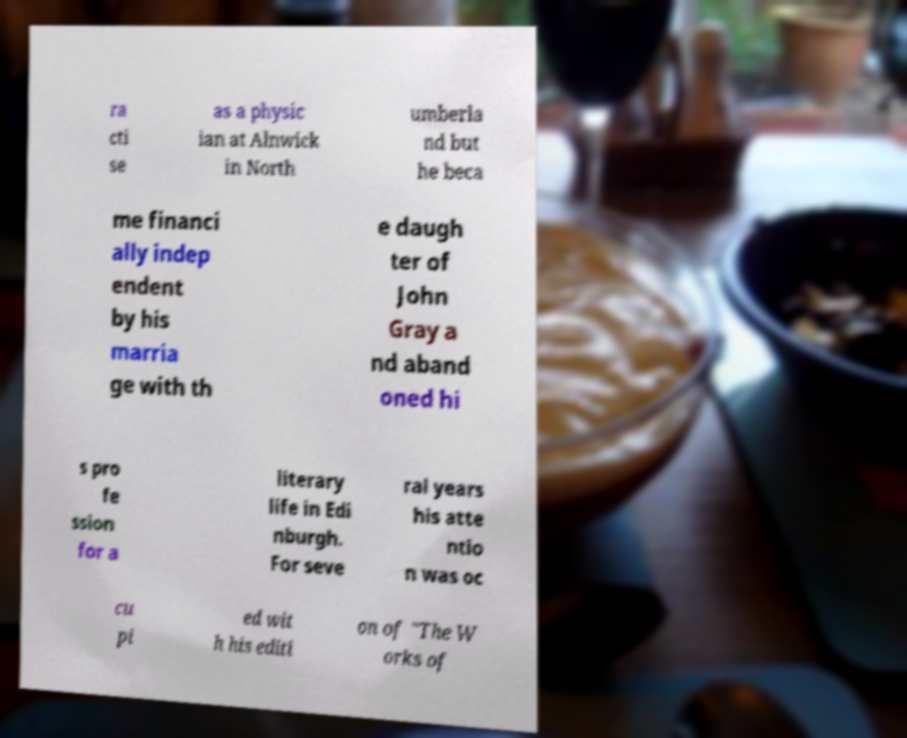Please identify and transcribe the text found in this image. ra cti se as a physic ian at Alnwick in North umberla nd but he beca me financi ally indep endent by his marria ge with th e daugh ter of John Gray a nd aband oned hi s pro fe ssion for a literary life in Edi nburgh. For seve ral years his atte ntio n was oc cu pi ed wit h his editi on of "The W orks of 